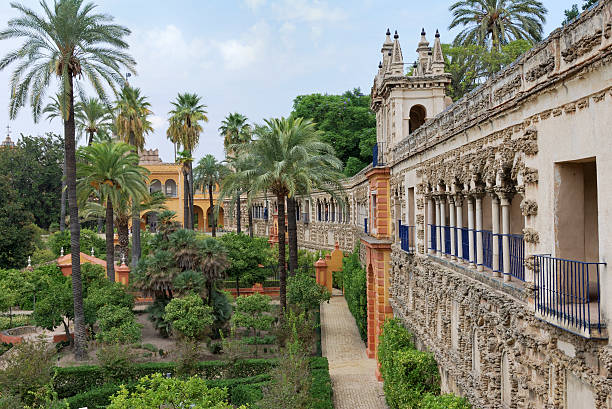What is this photo about? The image showcases the exquisite Alcazar Cathedral Gardens located in Seville, Spain. This view offers a sweeping overview of the myriad planting and architectural styles that reflect a rich tapestry of history, blending Moorish, Renaissance, and modern influences. These gardens are a patchwork of lush palm trees, manicured hedges, and intricately carved walkways, leading the eye toward ornate, historically significant buildings. Each element—from the vibrant greenery to the detailed stone carvings—tells a story of cultural amalgamation and royal heritage. The sky, peeking through gaps, adds a serene blue contrast to the earthy tones, emphasizing the tranquility and natural harmony of this famed landscape. 